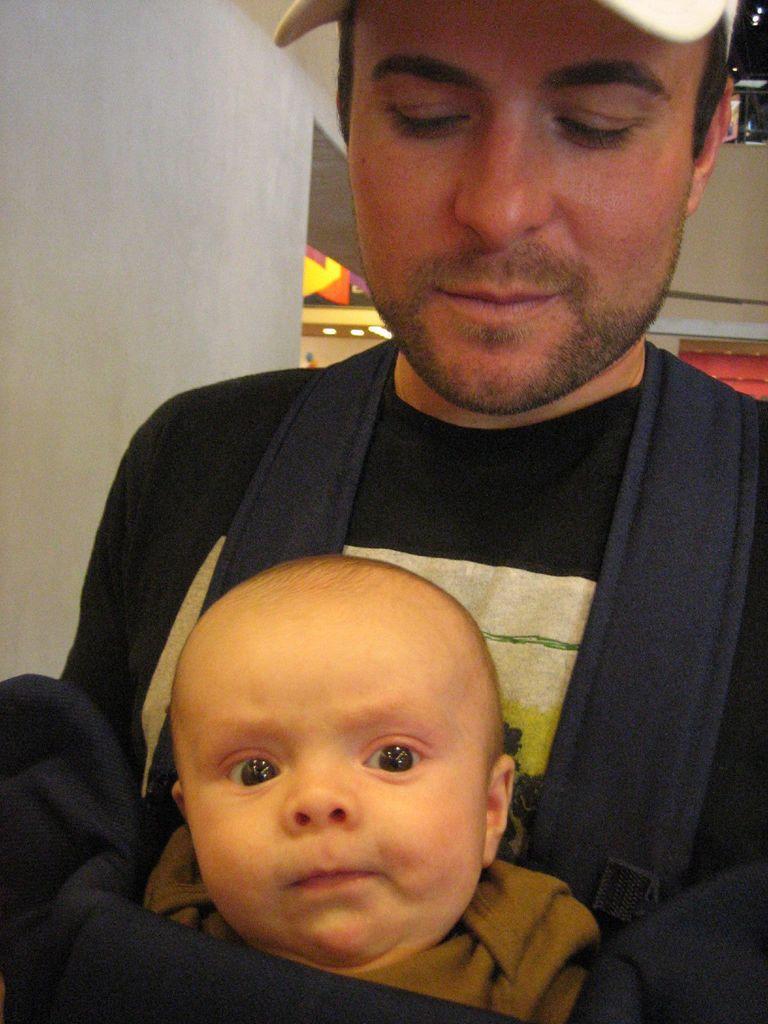How would you summarize this image in a sentence or two? Here in this picture we can see a person carrying a baby in the kangaroo bag present on him and we can see he is smiling and wearing cap on him. 